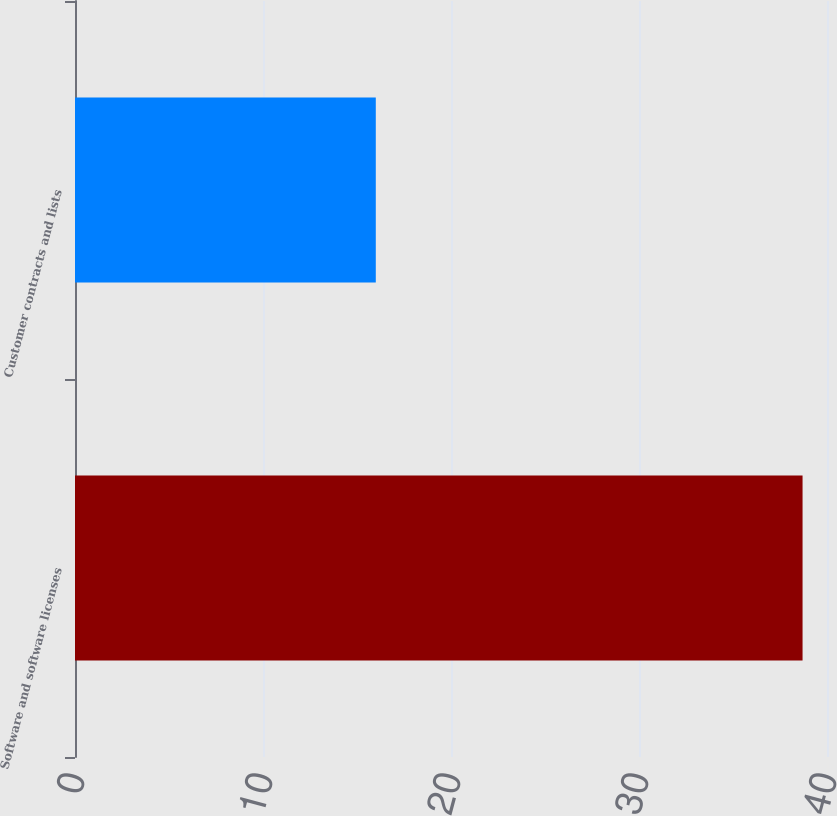<chart> <loc_0><loc_0><loc_500><loc_500><bar_chart><fcel>Software and software licenses<fcel>Customer contracts and lists<nl><fcel>38.7<fcel>16<nl></chart> 